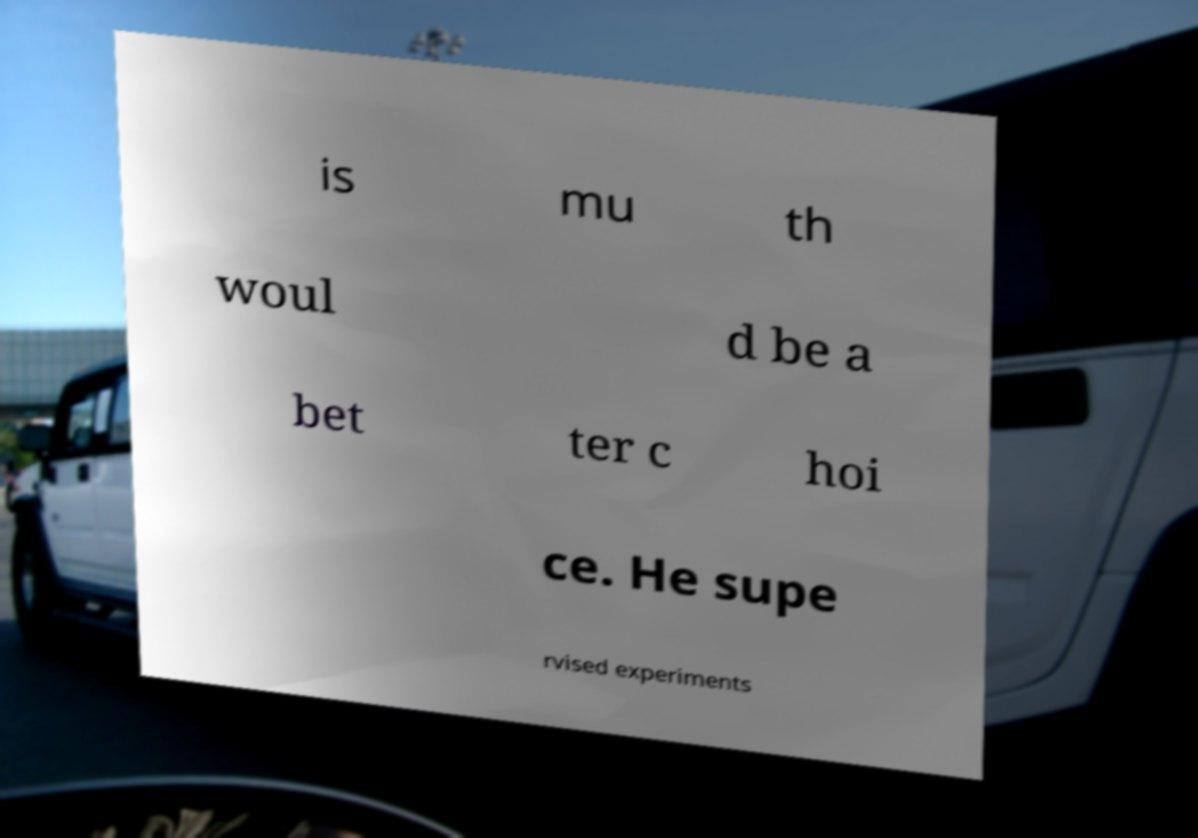Please identify and transcribe the text found in this image. is mu th woul d be a bet ter c hoi ce. He supe rvised experiments 